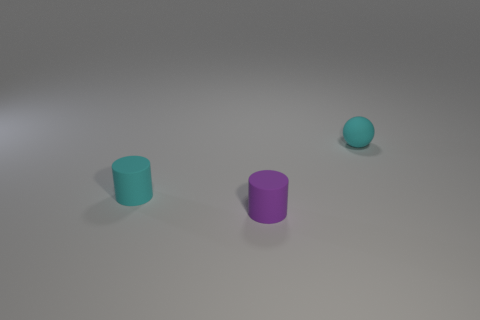Add 1 blue cubes. How many objects exist? 4 Subtract all balls. How many objects are left? 2 Subtract all cyan things. Subtract all cyan spheres. How many objects are left? 0 Add 2 small balls. How many small balls are left? 3 Add 2 small brown metallic cylinders. How many small brown metallic cylinders exist? 2 Subtract 0 blue balls. How many objects are left? 3 